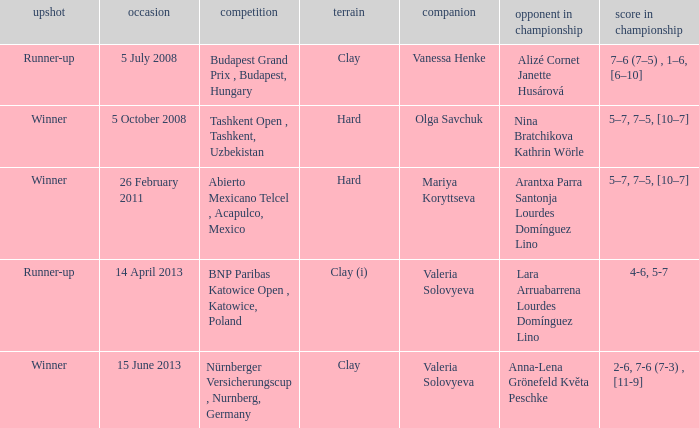Parse the full table. {'header': ['upshot', 'occasion', 'competition', 'terrain', 'companion', 'opponent in championship', 'score in championship'], 'rows': [['Runner-up', '5 July 2008', 'Budapest Grand Prix , Budapest, Hungary', 'Clay', 'Vanessa Henke', 'Alizé Cornet Janette Husárová', '7–6 (7–5) , 1–6, [6–10]'], ['Winner', '5 October 2008', 'Tashkent Open , Tashkent, Uzbekistan', 'Hard', 'Olga Savchuk', 'Nina Bratchikova Kathrin Wörle', '5–7, 7–5, [10–7]'], ['Winner', '26 February 2011', 'Abierto Mexicano Telcel , Acapulco, Mexico', 'Hard', 'Mariya Koryttseva', 'Arantxa Parra Santonja Lourdes Domínguez Lino', '5–7, 7–5, [10–7]'], ['Runner-up', '14 April 2013', 'BNP Paribas Katowice Open , Katowice, Poland', 'Clay (i)', 'Valeria Solovyeva', 'Lara Arruabarrena Lourdes Domínguez Lino', '4-6, 5-7'], ['Winner', '15 June 2013', 'Nürnberger Versicherungscup , Nurnberg, Germany', 'Clay', 'Valeria Solovyeva', 'Anna-Lena Grönefeld Květa Peschke', '2-6, 7-6 (7-3) , [11-9]']]} Name the outcome for alizé cornet janette husárová being opponent in final Runner-up. 